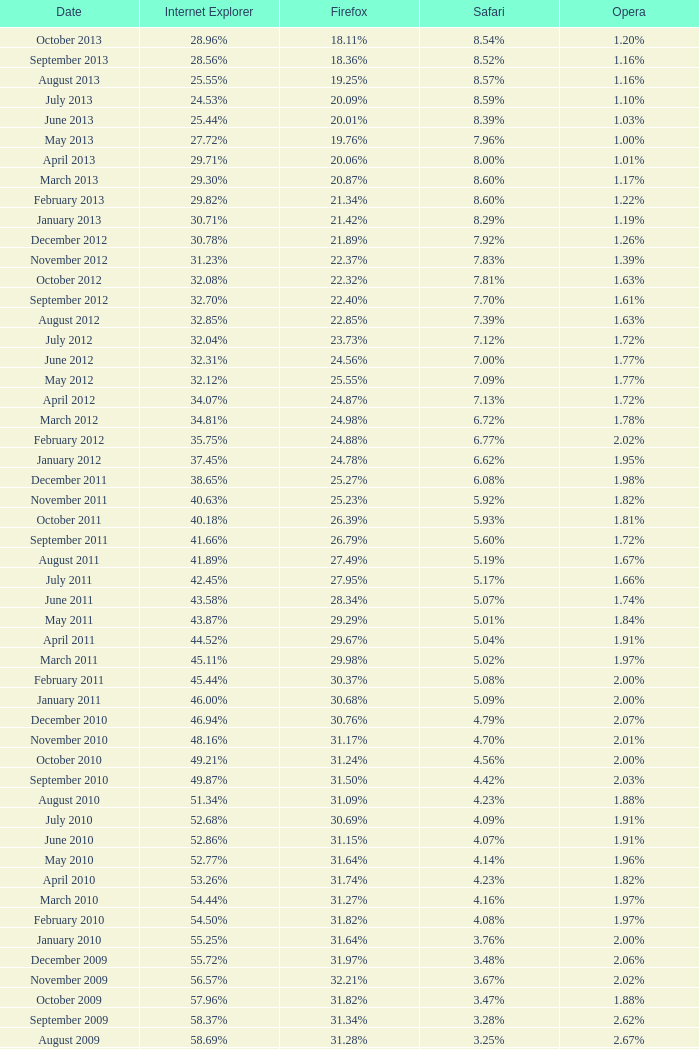What percentage of browsers were using Internet Explorer during the period in which 27.85% were using Firefox? 64.43%. 